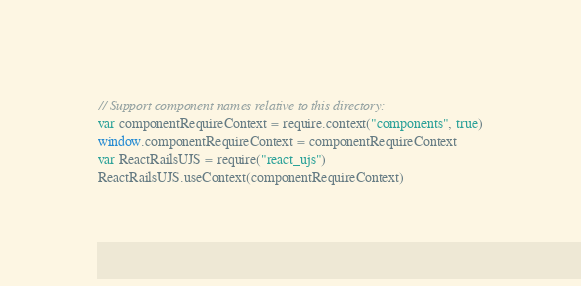<code> <loc_0><loc_0><loc_500><loc_500><_JavaScript_>// Support component names relative to this directory:
var componentRequireContext = require.context("components", true)
window.componentRequireContext = componentRequireContext
var ReactRailsUJS = require("react_ujs")
ReactRailsUJS.useContext(componentRequireContext)
</code> 